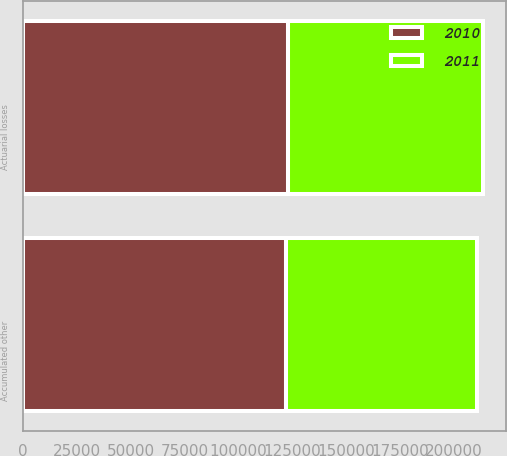<chart> <loc_0><loc_0><loc_500><loc_500><stacked_bar_chart><ecel><fcel>Actuarial losses<fcel>Accumulated other<nl><fcel>2010<fcel>123087<fcel>122174<nl><fcel>2011<fcel>90465<fcel>88751<nl></chart> 